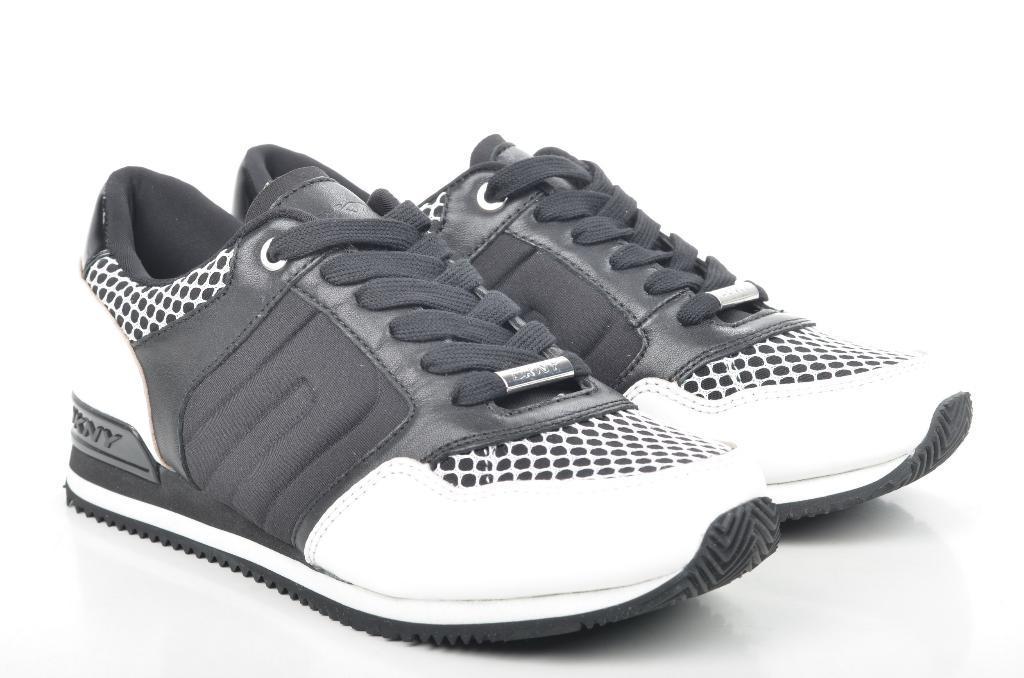How would you summarize this image in a sentence or two? In this image there is white background. We can see black and white shoes. 